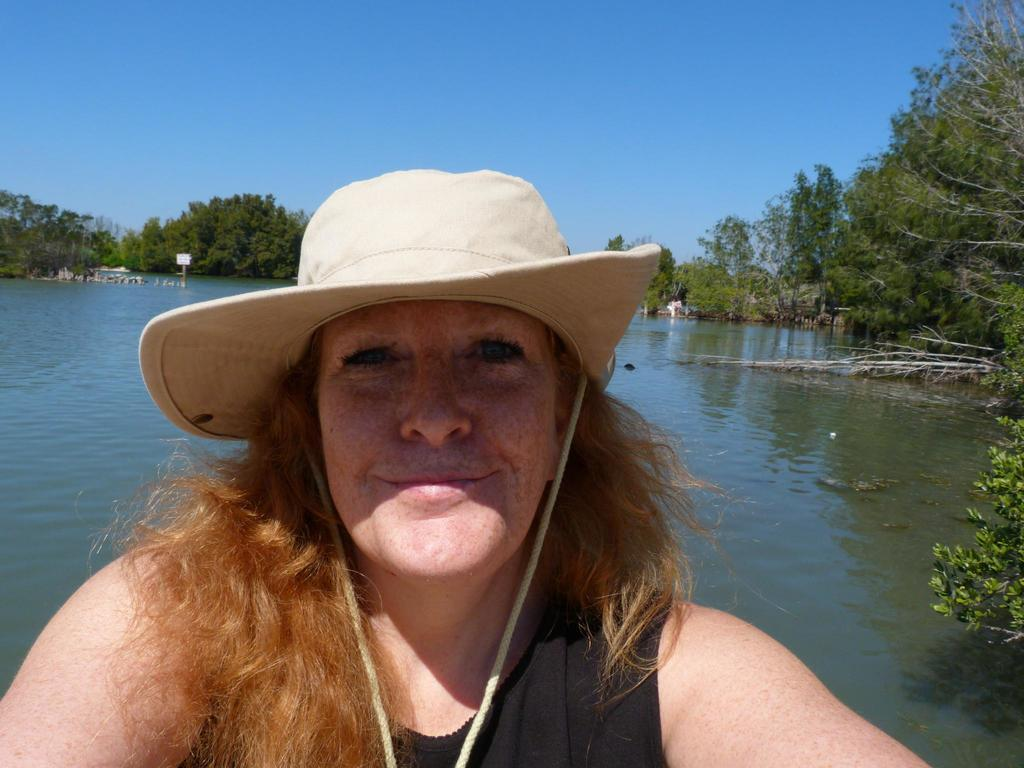Who is present in the image? There is a woman in the image. What is the woman wearing on her head? The woman is wearing a hat. What can be seen in the background of the image? There is water and trees visible in the background of the image. What is visible at the top of the image? The sky is visible at the top of the image. Is the man sleeping in the image? There is no man present in the image, so it cannot be determined if he is sleeping or not. Can you see any cows in the image? There are no cows visible in the image. 